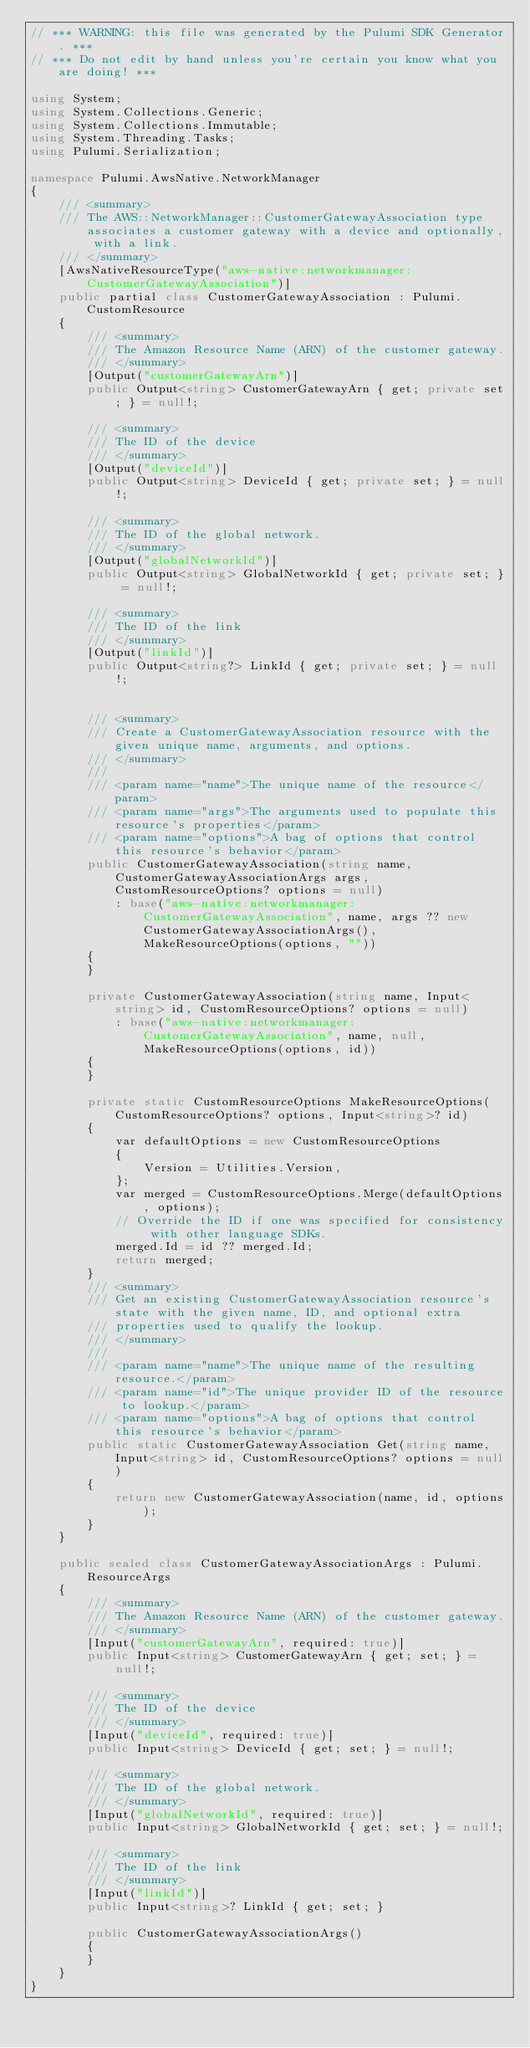<code> <loc_0><loc_0><loc_500><loc_500><_C#_>// *** WARNING: this file was generated by the Pulumi SDK Generator. ***
// *** Do not edit by hand unless you're certain you know what you are doing! ***

using System;
using System.Collections.Generic;
using System.Collections.Immutable;
using System.Threading.Tasks;
using Pulumi.Serialization;

namespace Pulumi.AwsNative.NetworkManager
{
    /// <summary>
    /// The AWS::NetworkManager::CustomerGatewayAssociation type associates a customer gateway with a device and optionally, with a link.
    /// </summary>
    [AwsNativeResourceType("aws-native:networkmanager:CustomerGatewayAssociation")]
    public partial class CustomerGatewayAssociation : Pulumi.CustomResource
    {
        /// <summary>
        /// The Amazon Resource Name (ARN) of the customer gateway.
        /// </summary>
        [Output("customerGatewayArn")]
        public Output<string> CustomerGatewayArn { get; private set; } = null!;

        /// <summary>
        /// The ID of the device
        /// </summary>
        [Output("deviceId")]
        public Output<string> DeviceId { get; private set; } = null!;

        /// <summary>
        /// The ID of the global network.
        /// </summary>
        [Output("globalNetworkId")]
        public Output<string> GlobalNetworkId { get; private set; } = null!;

        /// <summary>
        /// The ID of the link
        /// </summary>
        [Output("linkId")]
        public Output<string?> LinkId { get; private set; } = null!;


        /// <summary>
        /// Create a CustomerGatewayAssociation resource with the given unique name, arguments, and options.
        /// </summary>
        ///
        /// <param name="name">The unique name of the resource</param>
        /// <param name="args">The arguments used to populate this resource's properties</param>
        /// <param name="options">A bag of options that control this resource's behavior</param>
        public CustomerGatewayAssociation(string name, CustomerGatewayAssociationArgs args, CustomResourceOptions? options = null)
            : base("aws-native:networkmanager:CustomerGatewayAssociation", name, args ?? new CustomerGatewayAssociationArgs(), MakeResourceOptions(options, ""))
        {
        }

        private CustomerGatewayAssociation(string name, Input<string> id, CustomResourceOptions? options = null)
            : base("aws-native:networkmanager:CustomerGatewayAssociation", name, null, MakeResourceOptions(options, id))
        {
        }

        private static CustomResourceOptions MakeResourceOptions(CustomResourceOptions? options, Input<string>? id)
        {
            var defaultOptions = new CustomResourceOptions
            {
                Version = Utilities.Version,
            };
            var merged = CustomResourceOptions.Merge(defaultOptions, options);
            // Override the ID if one was specified for consistency with other language SDKs.
            merged.Id = id ?? merged.Id;
            return merged;
        }
        /// <summary>
        /// Get an existing CustomerGatewayAssociation resource's state with the given name, ID, and optional extra
        /// properties used to qualify the lookup.
        /// </summary>
        ///
        /// <param name="name">The unique name of the resulting resource.</param>
        /// <param name="id">The unique provider ID of the resource to lookup.</param>
        /// <param name="options">A bag of options that control this resource's behavior</param>
        public static CustomerGatewayAssociation Get(string name, Input<string> id, CustomResourceOptions? options = null)
        {
            return new CustomerGatewayAssociation(name, id, options);
        }
    }

    public sealed class CustomerGatewayAssociationArgs : Pulumi.ResourceArgs
    {
        /// <summary>
        /// The Amazon Resource Name (ARN) of the customer gateway.
        /// </summary>
        [Input("customerGatewayArn", required: true)]
        public Input<string> CustomerGatewayArn { get; set; } = null!;

        /// <summary>
        /// The ID of the device
        /// </summary>
        [Input("deviceId", required: true)]
        public Input<string> DeviceId { get; set; } = null!;

        /// <summary>
        /// The ID of the global network.
        /// </summary>
        [Input("globalNetworkId", required: true)]
        public Input<string> GlobalNetworkId { get; set; } = null!;

        /// <summary>
        /// The ID of the link
        /// </summary>
        [Input("linkId")]
        public Input<string>? LinkId { get; set; }

        public CustomerGatewayAssociationArgs()
        {
        }
    }
}
</code> 